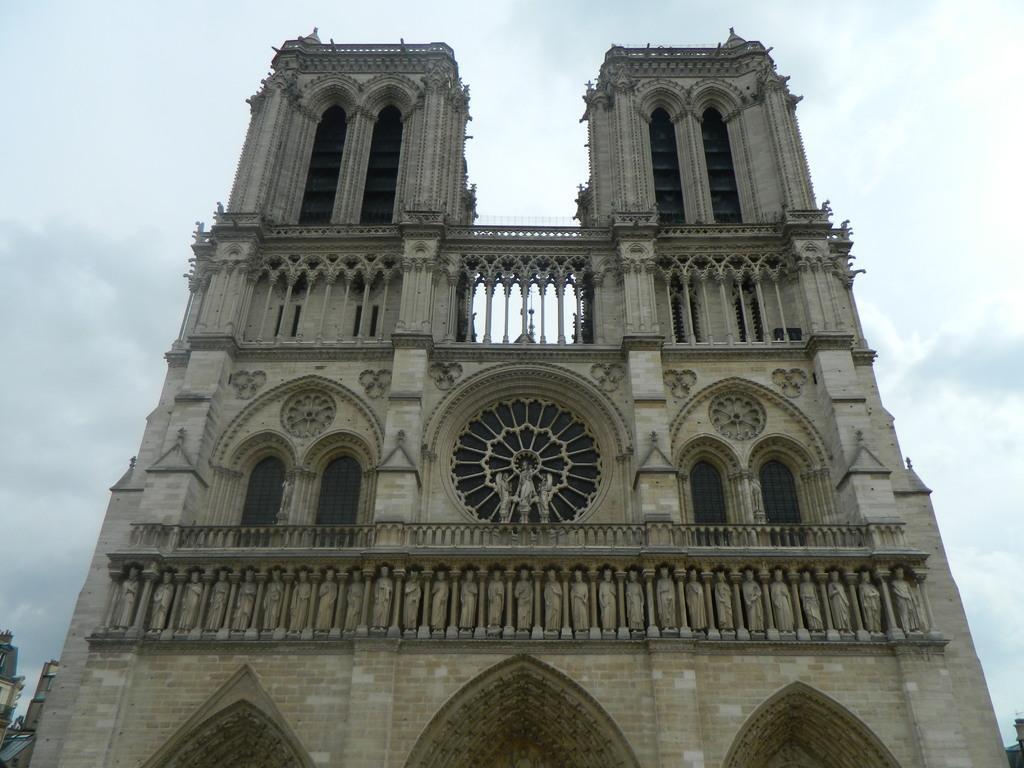Can you describe this image briefly? In this image I can see a building which is cream, brown and black in color. I can see few statues on the building. In the background I can see few other buildings and the sky. 